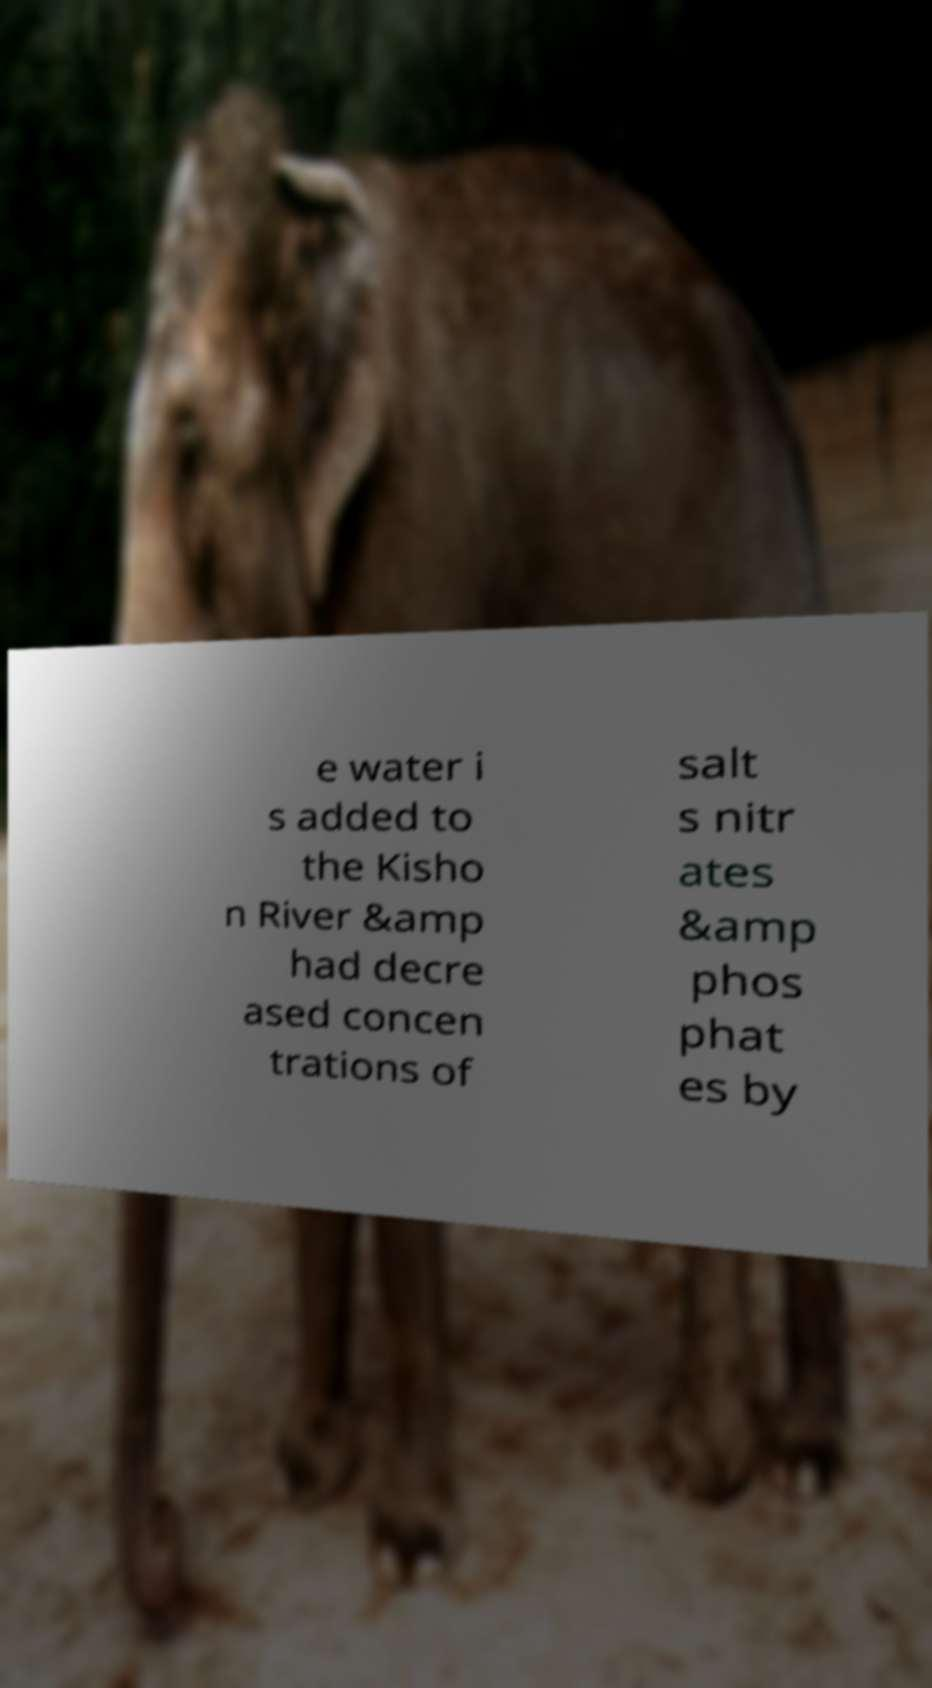There's text embedded in this image that I need extracted. Can you transcribe it verbatim? e water i s added to the Kisho n River &amp had decre ased concen trations of salt s nitr ates &amp phos phat es by 